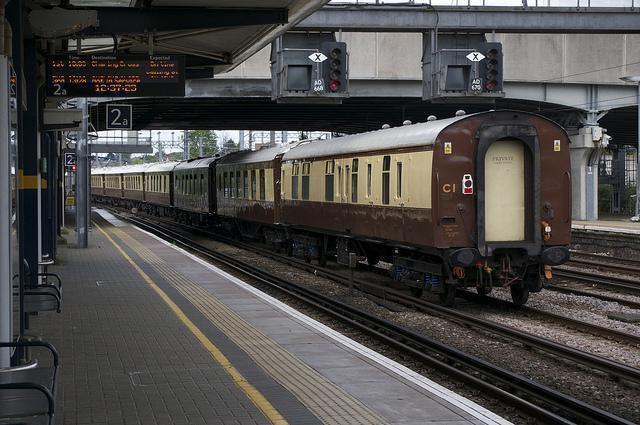What are the passengers told to wait behind?
Choose the correct response, then elucidate: 'Answer: answer
Rationale: rationale.'
Options: Yellow line, glass door, velvet rope, pylon. Answer: yellow line.
Rationale: The yellow line is for safety. 